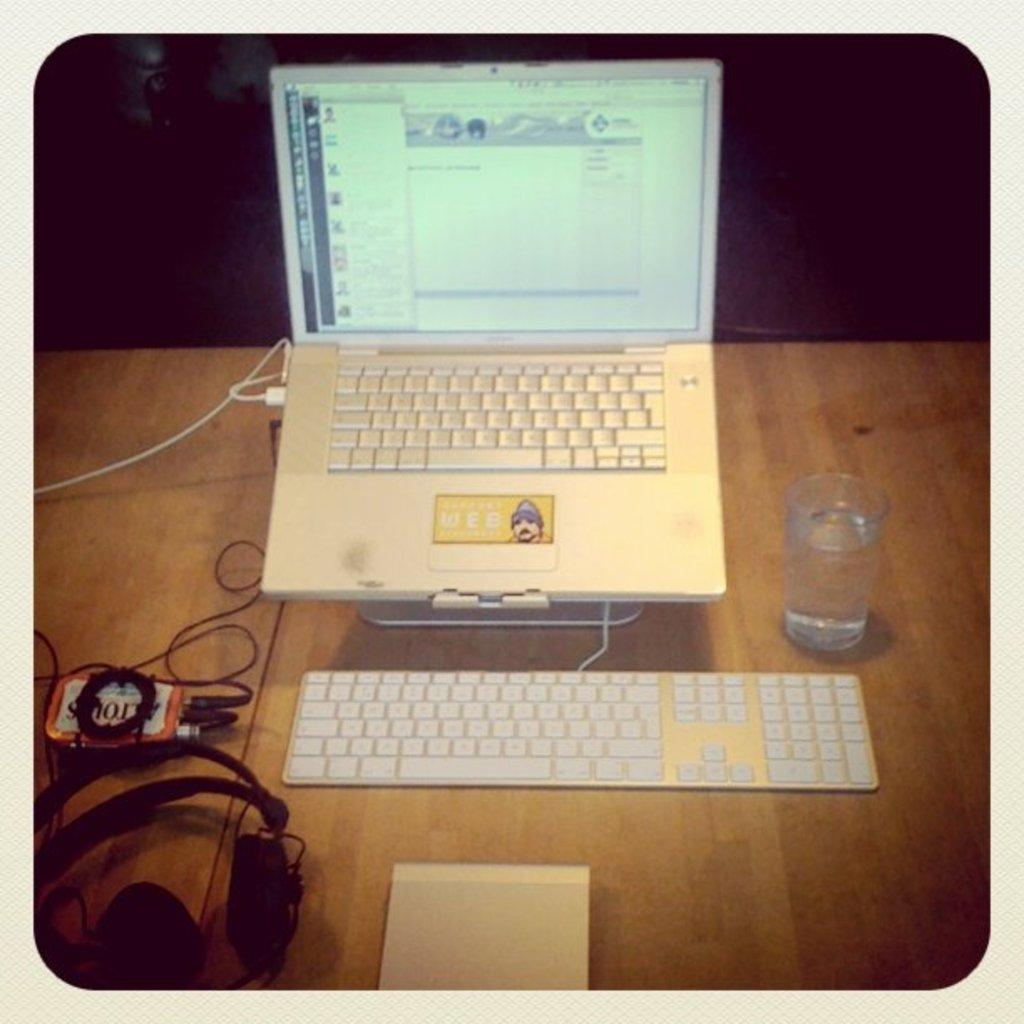<image>
Offer a succinct explanation of the picture presented. An open turned on laptop with periferals plugged into an Altoids can. 